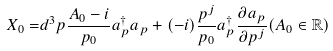<formula> <loc_0><loc_0><loc_500><loc_500>X _ { 0 } = & d ^ { 3 } p \frac { A _ { 0 } - i } { p _ { 0 } } a _ { p } ^ { \dagger } a _ { p } + ( - i ) \frac { p ^ { j } } { p _ { 0 } } a _ { p } ^ { \dagger } \frac { \partial a _ { p } } { \partial p ^ { j } } ( A _ { 0 } \in \mathbb { R } )</formula> 